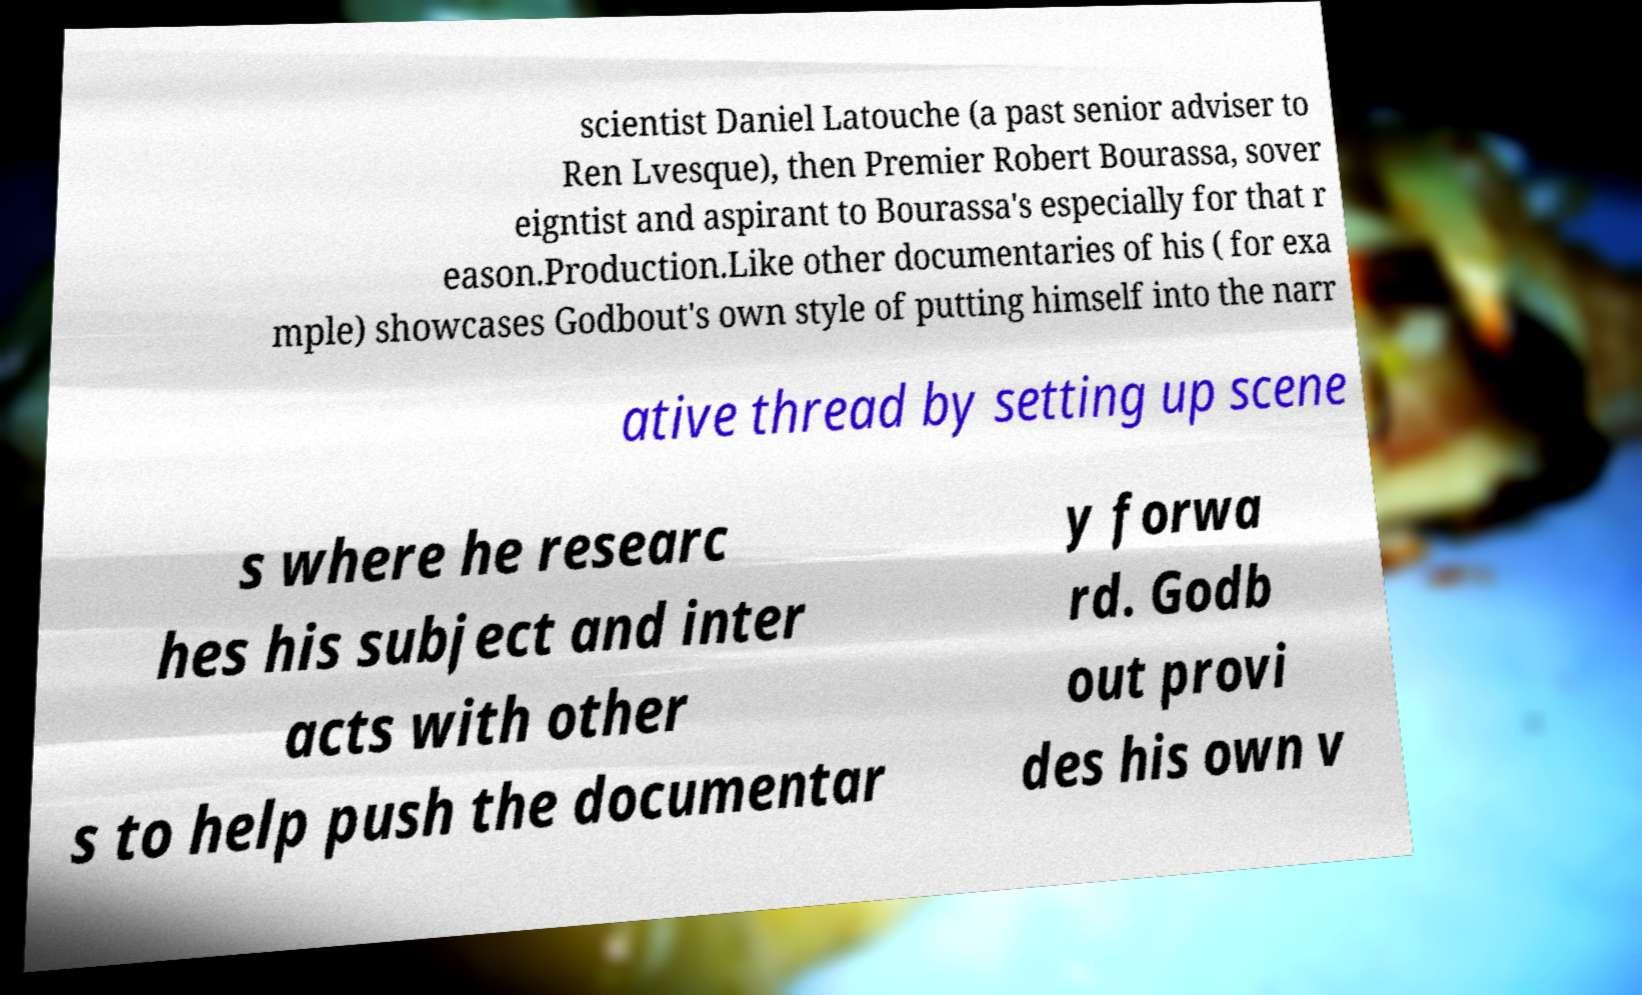Please identify and transcribe the text found in this image. scientist Daniel Latouche (a past senior adviser to Ren Lvesque), then Premier Robert Bourassa, sover eigntist and aspirant to Bourassa's especially for that r eason.Production.Like other documentaries of his ( for exa mple) showcases Godbout's own style of putting himself into the narr ative thread by setting up scene s where he researc hes his subject and inter acts with other s to help push the documentar y forwa rd. Godb out provi des his own v 